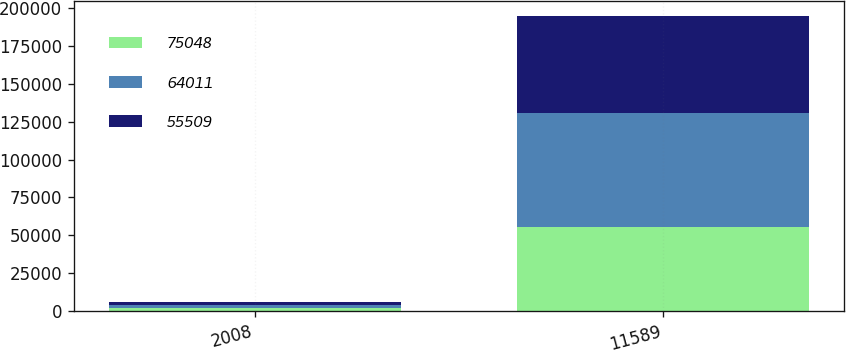Convert chart. <chart><loc_0><loc_0><loc_500><loc_500><stacked_bar_chart><ecel><fcel>2008<fcel>11589<nl><fcel>75048<fcel>2007<fcel>55509<nl><fcel>64011<fcel>2006<fcel>75048<nl><fcel>55509<fcel>2005<fcel>64011<nl></chart> 